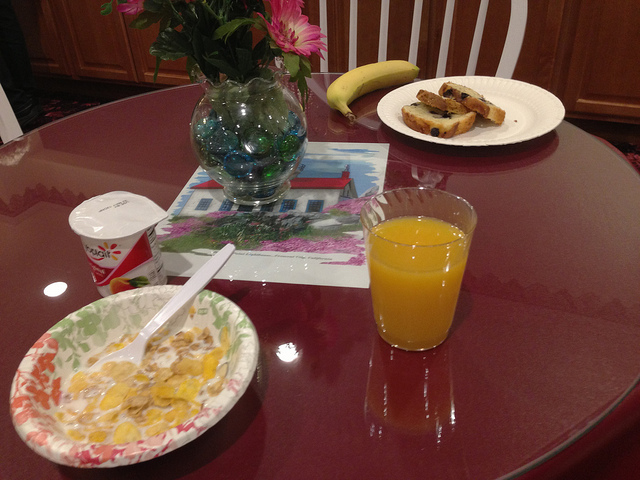What fruit used to prepare items here is darkest?
A. blueberries
B. apricots
C. bananas
D. oranges
Answer with the option's letter from the given choices directly. A 